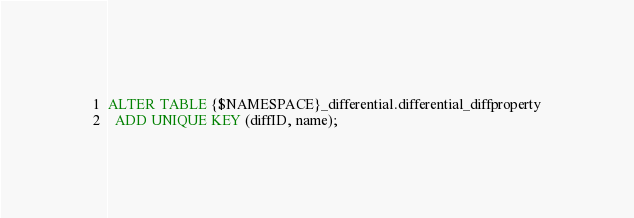Convert code to text. <code><loc_0><loc_0><loc_500><loc_500><_SQL_>ALTER TABLE {$NAMESPACE}_differential.differential_diffproperty
  ADD UNIQUE KEY (diffID, name);
</code> 